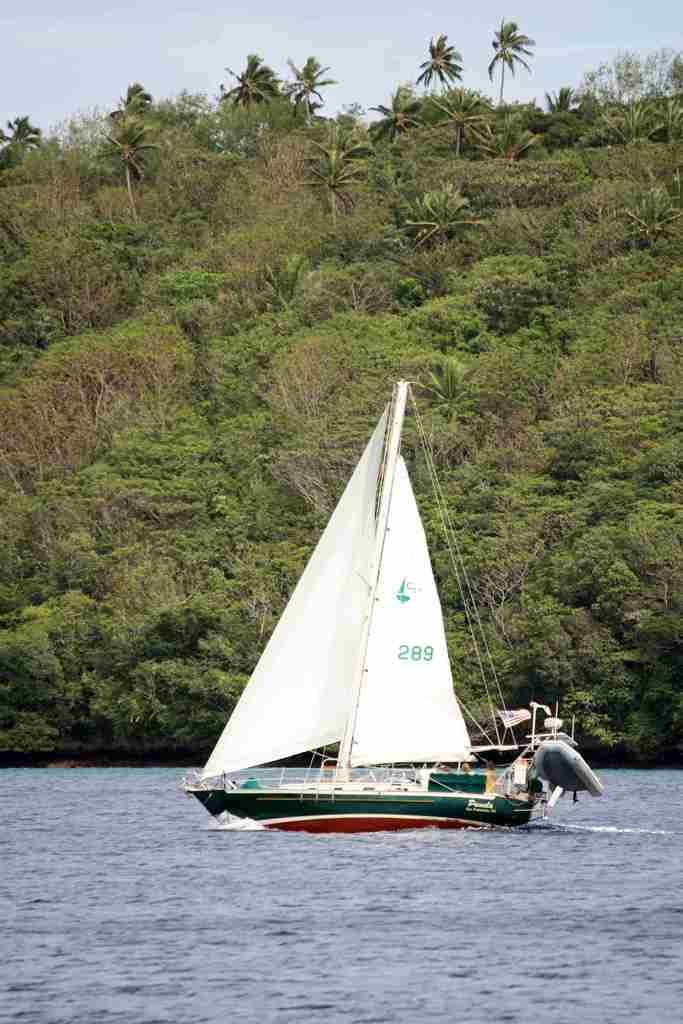What is the main subject of the image? The main subject of the image is a boat. Where is the boat located? The boat is on the water. What can be seen on the boat? There is a pole and ropes on the boat. What is visible in the background of the image? Trees and the sky are visible in the background of the image. How many pages does the team need to turn in order to reach the boat in the image? There are no pages or teams present in the image; it features a boat on the water with a pole and ropes. Can you tell me how many bites the boat has taken out of the trees in the background? The boat does not have the ability to take bites, and there are no trees being affected by the boat in the image. 